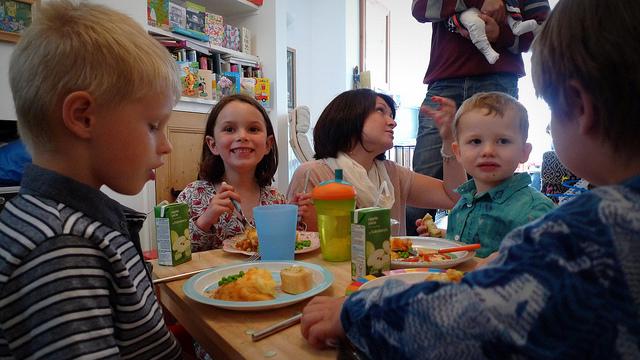Is the woman happy?
Short answer required. No. How many people are at the table?
Write a very short answer. 5. What color are the child's eyes looking behind to the camera?
Answer briefly. Brown. How many children are in the image?
Concise answer only. 4. What came in the green box?
Give a very brief answer. Juice. How many girls are in the picture?
Write a very short answer. 2. Are the people both looking at the same thing?
Be succinct. No. Where is the pic taken?
Answer briefly. Kitchen. Does the boy have pizza on his plate?
Quick response, please. No. What type of dining function is this?
Quick response, please. Lunch. What type of food is on the plate?
Write a very short answer. Children's food. Is there an orange tray on the table?
Give a very brief answer. No. Is this a young people's gathering?
Be succinct. Yes. What is the little boy wearing?
Keep it brief. Shirt. How many of the children are boys?
Write a very short answer. 3. Is this edible?
Concise answer only. Yes. How many children are there?
Give a very brief answer. 4. Is there any juice on the table?
Write a very short answer. Yes. Is fruit a component of some of these edibles?
Quick response, please. Yes. 